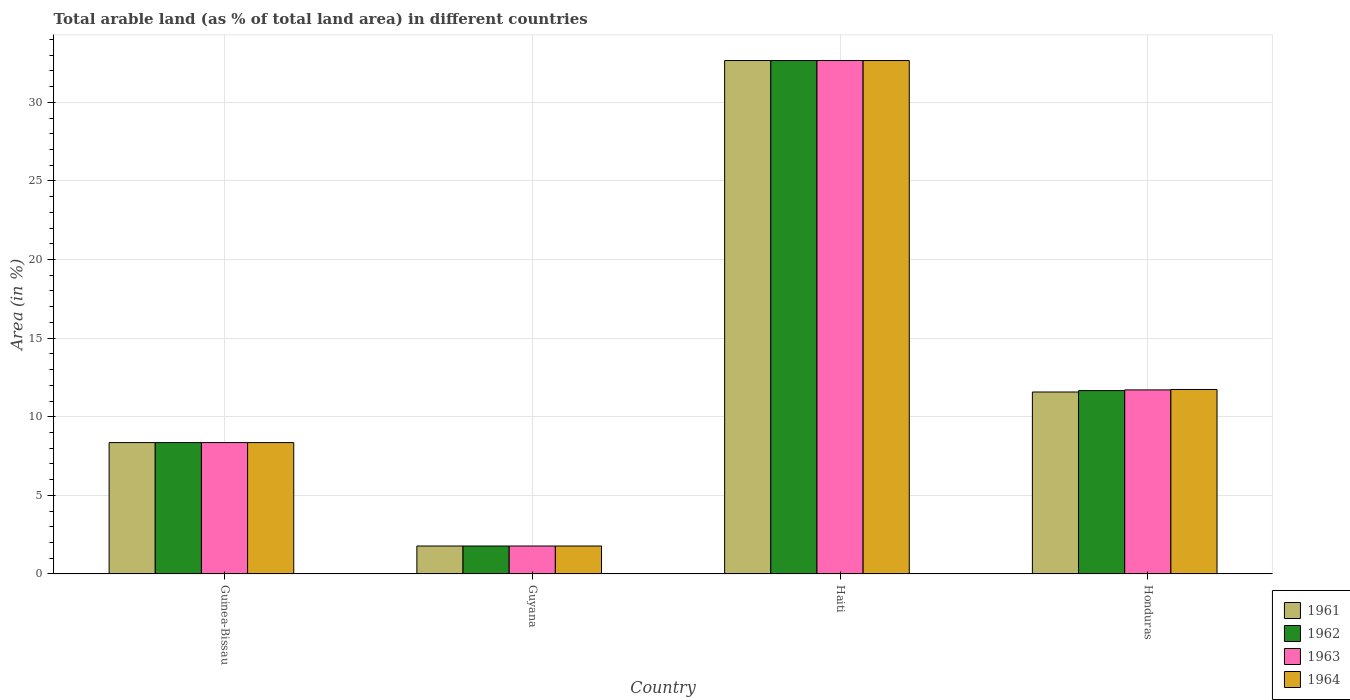How many different coloured bars are there?
Your answer should be compact. 4. How many groups of bars are there?
Your answer should be compact. 4. How many bars are there on the 1st tick from the left?
Offer a terse response. 4. How many bars are there on the 2nd tick from the right?
Ensure brevity in your answer.  4. What is the label of the 4th group of bars from the left?
Ensure brevity in your answer.  Honduras. In how many cases, is the number of bars for a given country not equal to the number of legend labels?
Offer a terse response. 0. What is the percentage of arable land in 1963 in Haiti?
Your response must be concise. 32.66. Across all countries, what is the maximum percentage of arable land in 1963?
Ensure brevity in your answer.  32.66. Across all countries, what is the minimum percentage of arable land in 1961?
Ensure brevity in your answer.  1.78. In which country was the percentage of arable land in 1964 maximum?
Offer a terse response. Haiti. In which country was the percentage of arable land in 1963 minimum?
Your answer should be compact. Guyana. What is the total percentage of arable land in 1962 in the graph?
Offer a terse response. 54.46. What is the difference between the percentage of arable land in 1961 in Haiti and that in Honduras?
Offer a very short reply. 21.08. What is the difference between the percentage of arable land in 1963 in Honduras and the percentage of arable land in 1962 in Haiti?
Give a very brief answer. -20.95. What is the average percentage of arable land in 1962 per country?
Your response must be concise. 13.61. What is the difference between the percentage of arable land of/in 1963 and percentage of arable land of/in 1961 in Haiti?
Keep it short and to the point. 0. What is the ratio of the percentage of arable land in 1964 in Guyana to that in Haiti?
Offer a very short reply. 0.05. Is the percentage of arable land in 1964 in Guyana less than that in Haiti?
Provide a short and direct response. Yes. Is the difference between the percentage of arable land in 1963 in Haiti and Honduras greater than the difference between the percentage of arable land in 1961 in Haiti and Honduras?
Offer a very short reply. No. What is the difference between the highest and the second highest percentage of arable land in 1962?
Provide a succinct answer. 24.3. What is the difference between the highest and the lowest percentage of arable land in 1962?
Your answer should be compact. 30.88. What does the 4th bar from the left in Haiti represents?
Offer a terse response. 1964. What does the 2nd bar from the right in Haiti represents?
Offer a terse response. 1963. Are all the bars in the graph horizontal?
Provide a succinct answer. No. What is the difference between two consecutive major ticks on the Y-axis?
Your response must be concise. 5. Are the values on the major ticks of Y-axis written in scientific E-notation?
Provide a succinct answer. No. Does the graph contain any zero values?
Offer a terse response. No. Does the graph contain grids?
Provide a short and direct response. Yes. What is the title of the graph?
Offer a terse response. Total arable land (as % of total land area) in different countries. What is the label or title of the X-axis?
Your response must be concise. Country. What is the label or title of the Y-axis?
Provide a succinct answer. Area (in %). What is the Area (in %) of 1961 in Guinea-Bissau?
Offer a terse response. 8.36. What is the Area (in %) of 1962 in Guinea-Bissau?
Make the answer very short. 8.36. What is the Area (in %) of 1963 in Guinea-Bissau?
Keep it short and to the point. 8.36. What is the Area (in %) of 1964 in Guinea-Bissau?
Your response must be concise. 8.36. What is the Area (in %) in 1961 in Guyana?
Make the answer very short. 1.78. What is the Area (in %) of 1962 in Guyana?
Give a very brief answer. 1.78. What is the Area (in %) in 1963 in Guyana?
Keep it short and to the point. 1.78. What is the Area (in %) in 1964 in Guyana?
Provide a short and direct response. 1.78. What is the Area (in %) of 1961 in Haiti?
Your answer should be compact. 32.66. What is the Area (in %) in 1962 in Haiti?
Provide a short and direct response. 32.66. What is the Area (in %) in 1963 in Haiti?
Provide a succinct answer. 32.66. What is the Area (in %) of 1964 in Haiti?
Keep it short and to the point. 32.66. What is the Area (in %) of 1961 in Honduras?
Keep it short and to the point. 11.57. What is the Area (in %) of 1962 in Honduras?
Keep it short and to the point. 11.66. What is the Area (in %) in 1963 in Honduras?
Keep it short and to the point. 11.71. What is the Area (in %) of 1964 in Honduras?
Your answer should be very brief. 11.73. Across all countries, what is the maximum Area (in %) of 1961?
Provide a short and direct response. 32.66. Across all countries, what is the maximum Area (in %) of 1962?
Provide a short and direct response. 32.66. Across all countries, what is the maximum Area (in %) in 1963?
Offer a terse response. 32.66. Across all countries, what is the maximum Area (in %) of 1964?
Your answer should be very brief. 32.66. Across all countries, what is the minimum Area (in %) of 1961?
Offer a very short reply. 1.78. Across all countries, what is the minimum Area (in %) of 1962?
Provide a succinct answer. 1.78. Across all countries, what is the minimum Area (in %) of 1963?
Offer a terse response. 1.78. Across all countries, what is the minimum Area (in %) of 1964?
Provide a short and direct response. 1.78. What is the total Area (in %) of 1961 in the graph?
Ensure brevity in your answer.  54.37. What is the total Area (in %) of 1962 in the graph?
Offer a very short reply. 54.46. What is the total Area (in %) of 1963 in the graph?
Your answer should be compact. 54.5. What is the total Area (in %) of 1964 in the graph?
Your response must be concise. 54.53. What is the difference between the Area (in %) of 1961 in Guinea-Bissau and that in Guyana?
Offer a terse response. 6.58. What is the difference between the Area (in %) in 1962 in Guinea-Bissau and that in Guyana?
Give a very brief answer. 6.58. What is the difference between the Area (in %) of 1963 in Guinea-Bissau and that in Guyana?
Offer a very short reply. 6.58. What is the difference between the Area (in %) in 1964 in Guinea-Bissau and that in Guyana?
Provide a succinct answer. 6.58. What is the difference between the Area (in %) in 1961 in Guinea-Bissau and that in Haiti?
Provide a succinct answer. -24.3. What is the difference between the Area (in %) in 1962 in Guinea-Bissau and that in Haiti?
Give a very brief answer. -24.3. What is the difference between the Area (in %) in 1963 in Guinea-Bissau and that in Haiti?
Provide a short and direct response. -24.3. What is the difference between the Area (in %) of 1964 in Guinea-Bissau and that in Haiti?
Give a very brief answer. -24.3. What is the difference between the Area (in %) of 1961 in Guinea-Bissau and that in Honduras?
Your answer should be compact. -3.22. What is the difference between the Area (in %) of 1962 in Guinea-Bissau and that in Honduras?
Your answer should be compact. -3.31. What is the difference between the Area (in %) of 1963 in Guinea-Bissau and that in Honduras?
Make the answer very short. -3.35. What is the difference between the Area (in %) of 1964 in Guinea-Bissau and that in Honduras?
Your answer should be compact. -3.38. What is the difference between the Area (in %) in 1961 in Guyana and that in Haiti?
Your response must be concise. -30.88. What is the difference between the Area (in %) in 1962 in Guyana and that in Haiti?
Offer a terse response. -30.88. What is the difference between the Area (in %) of 1963 in Guyana and that in Haiti?
Make the answer very short. -30.88. What is the difference between the Area (in %) of 1964 in Guyana and that in Haiti?
Offer a terse response. -30.88. What is the difference between the Area (in %) of 1961 in Guyana and that in Honduras?
Make the answer very short. -9.79. What is the difference between the Area (in %) in 1962 in Guyana and that in Honduras?
Your answer should be very brief. -9.88. What is the difference between the Area (in %) in 1963 in Guyana and that in Honduras?
Give a very brief answer. -9.93. What is the difference between the Area (in %) in 1964 in Guyana and that in Honduras?
Give a very brief answer. -9.96. What is the difference between the Area (in %) of 1961 in Haiti and that in Honduras?
Your answer should be very brief. 21.08. What is the difference between the Area (in %) of 1962 in Haiti and that in Honduras?
Your answer should be compact. 20.99. What is the difference between the Area (in %) of 1963 in Haiti and that in Honduras?
Offer a terse response. 20.95. What is the difference between the Area (in %) of 1964 in Haiti and that in Honduras?
Your answer should be very brief. 20.92. What is the difference between the Area (in %) of 1961 in Guinea-Bissau and the Area (in %) of 1962 in Guyana?
Your answer should be very brief. 6.58. What is the difference between the Area (in %) in 1961 in Guinea-Bissau and the Area (in %) in 1963 in Guyana?
Give a very brief answer. 6.58. What is the difference between the Area (in %) in 1961 in Guinea-Bissau and the Area (in %) in 1964 in Guyana?
Offer a terse response. 6.58. What is the difference between the Area (in %) in 1962 in Guinea-Bissau and the Area (in %) in 1963 in Guyana?
Keep it short and to the point. 6.58. What is the difference between the Area (in %) of 1962 in Guinea-Bissau and the Area (in %) of 1964 in Guyana?
Keep it short and to the point. 6.58. What is the difference between the Area (in %) in 1963 in Guinea-Bissau and the Area (in %) in 1964 in Guyana?
Offer a terse response. 6.58. What is the difference between the Area (in %) in 1961 in Guinea-Bissau and the Area (in %) in 1962 in Haiti?
Offer a terse response. -24.3. What is the difference between the Area (in %) of 1961 in Guinea-Bissau and the Area (in %) of 1963 in Haiti?
Make the answer very short. -24.3. What is the difference between the Area (in %) in 1961 in Guinea-Bissau and the Area (in %) in 1964 in Haiti?
Offer a very short reply. -24.3. What is the difference between the Area (in %) of 1962 in Guinea-Bissau and the Area (in %) of 1963 in Haiti?
Provide a succinct answer. -24.3. What is the difference between the Area (in %) of 1962 in Guinea-Bissau and the Area (in %) of 1964 in Haiti?
Your response must be concise. -24.3. What is the difference between the Area (in %) in 1963 in Guinea-Bissau and the Area (in %) in 1964 in Haiti?
Provide a short and direct response. -24.3. What is the difference between the Area (in %) in 1961 in Guinea-Bissau and the Area (in %) in 1962 in Honduras?
Offer a terse response. -3.31. What is the difference between the Area (in %) in 1961 in Guinea-Bissau and the Area (in %) in 1963 in Honduras?
Ensure brevity in your answer.  -3.35. What is the difference between the Area (in %) of 1961 in Guinea-Bissau and the Area (in %) of 1964 in Honduras?
Offer a terse response. -3.38. What is the difference between the Area (in %) of 1962 in Guinea-Bissau and the Area (in %) of 1963 in Honduras?
Your answer should be very brief. -3.35. What is the difference between the Area (in %) in 1962 in Guinea-Bissau and the Area (in %) in 1964 in Honduras?
Give a very brief answer. -3.38. What is the difference between the Area (in %) of 1963 in Guinea-Bissau and the Area (in %) of 1964 in Honduras?
Provide a succinct answer. -3.38. What is the difference between the Area (in %) of 1961 in Guyana and the Area (in %) of 1962 in Haiti?
Ensure brevity in your answer.  -30.88. What is the difference between the Area (in %) of 1961 in Guyana and the Area (in %) of 1963 in Haiti?
Make the answer very short. -30.88. What is the difference between the Area (in %) in 1961 in Guyana and the Area (in %) in 1964 in Haiti?
Offer a terse response. -30.88. What is the difference between the Area (in %) of 1962 in Guyana and the Area (in %) of 1963 in Haiti?
Make the answer very short. -30.88. What is the difference between the Area (in %) of 1962 in Guyana and the Area (in %) of 1964 in Haiti?
Your answer should be compact. -30.88. What is the difference between the Area (in %) of 1963 in Guyana and the Area (in %) of 1964 in Haiti?
Your answer should be compact. -30.88. What is the difference between the Area (in %) of 1961 in Guyana and the Area (in %) of 1962 in Honduras?
Make the answer very short. -9.88. What is the difference between the Area (in %) of 1961 in Guyana and the Area (in %) of 1963 in Honduras?
Your response must be concise. -9.93. What is the difference between the Area (in %) in 1961 in Guyana and the Area (in %) in 1964 in Honduras?
Provide a succinct answer. -9.96. What is the difference between the Area (in %) in 1962 in Guyana and the Area (in %) in 1963 in Honduras?
Ensure brevity in your answer.  -9.93. What is the difference between the Area (in %) in 1962 in Guyana and the Area (in %) in 1964 in Honduras?
Keep it short and to the point. -9.96. What is the difference between the Area (in %) of 1963 in Guyana and the Area (in %) of 1964 in Honduras?
Ensure brevity in your answer.  -9.96. What is the difference between the Area (in %) in 1961 in Haiti and the Area (in %) in 1962 in Honduras?
Provide a succinct answer. 20.99. What is the difference between the Area (in %) in 1961 in Haiti and the Area (in %) in 1963 in Honduras?
Your response must be concise. 20.95. What is the difference between the Area (in %) in 1961 in Haiti and the Area (in %) in 1964 in Honduras?
Your answer should be very brief. 20.92. What is the difference between the Area (in %) of 1962 in Haiti and the Area (in %) of 1963 in Honduras?
Your answer should be very brief. 20.95. What is the difference between the Area (in %) of 1962 in Haiti and the Area (in %) of 1964 in Honduras?
Your answer should be very brief. 20.92. What is the difference between the Area (in %) in 1963 in Haiti and the Area (in %) in 1964 in Honduras?
Provide a succinct answer. 20.92. What is the average Area (in %) in 1961 per country?
Ensure brevity in your answer.  13.59. What is the average Area (in %) in 1962 per country?
Your answer should be compact. 13.61. What is the average Area (in %) of 1963 per country?
Ensure brevity in your answer.  13.63. What is the average Area (in %) of 1964 per country?
Offer a very short reply. 13.63. What is the difference between the Area (in %) of 1962 and Area (in %) of 1964 in Guinea-Bissau?
Your answer should be compact. 0. What is the difference between the Area (in %) of 1963 and Area (in %) of 1964 in Guinea-Bissau?
Offer a very short reply. 0. What is the difference between the Area (in %) in 1961 and Area (in %) in 1962 in Guyana?
Make the answer very short. 0. What is the difference between the Area (in %) in 1961 and Area (in %) in 1963 in Guyana?
Your answer should be compact. 0. What is the difference between the Area (in %) in 1961 and Area (in %) in 1964 in Guyana?
Your response must be concise. 0. What is the difference between the Area (in %) in 1962 and Area (in %) in 1963 in Guyana?
Keep it short and to the point. 0. What is the difference between the Area (in %) in 1963 and Area (in %) in 1964 in Guyana?
Offer a terse response. 0. What is the difference between the Area (in %) of 1961 and Area (in %) of 1962 in Haiti?
Your response must be concise. 0. What is the difference between the Area (in %) in 1961 and Area (in %) in 1964 in Haiti?
Provide a succinct answer. 0. What is the difference between the Area (in %) in 1962 and Area (in %) in 1964 in Haiti?
Keep it short and to the point. 0. What is the difference between the Area (in %) in 1961 and Area (in %) in 1962 in Honduras?
Offer a terse response. -0.09. What is the difference between the Area (in %) in 1961 and Area (in %) in 1963 in Honduras?
Offer a terse response. -0.13. What is the difference between the Area (in %) of 1961 and Area (in %) of 1964 in Honduras?
Provide a succinct answer. -0.16. What is the difference between the Area (in %) of 1962 and Area (in %) of 1963 in Honduras?
Your answer should be very brief. -0.04. What is the difference between the Area (in %) in 1962 and Area (in %) in 1964 in Honduras?
Provide a short and direct response. -0.07. What is the difference between the Area (in %) in 1963 and Area (in %) in 1964 in Honduras?
Your answer should be very brief. -0.03. What is the ratio of the Area (in %) in 1961 in Guinea-Bissau to that in Guyana?
Offer a terse response. 4.7. What is the ratio of the Area (in %) of 1962 in Guinea-Bissau to that in Guyana?
Offer a very short reply. 4.7. What is the ratio of the Area (in %) in 1963 in Guinea-Bissau to that in Guyana?
Provide a short and direct response. 4.7. What is the ratio of the Area (in %) of 1964 in Guinea-Bissau to that in Guyana?
Offer a terse response. 4.7. What is the ratio of the Area (in %) of 1961 in Guinea-Bissau to that in Haiti?
Your answer should be very brief. 0.26. What is the ratio of the Area (in %) of 1962 in Guinea-Bissau to that in Haiti?
Your answer should be compact. 0.26. What is the ratio of the Area (in %) in 1963 in Guinea-Bissau to that in Haiti?
Your answer should be very brief. 0.26. What is the ratio of the Area (in %) in 1964 in Guinea-Bissau to that in Haiti?
Ensure brevity in your answer.  0.26. What is the ratio of the Area (in %) of 1961 in Guinea-Bissau to that in Honduras?
Give a very brief answer. 0.72. What is the ratio of the Area (in %) of 1962 in Guinea-Bissau to that in Honduras?
Give a very brief answer. 0.72. What is the ratio of the Area (in %) of 1963 in Guinea-Bissau to that in Honduras?
Your response must be concise. 0.71. What is the ratio of the Area (in %) in 1964 in Guinea-Bissau to that in Honduras?
Offer a very short reply. 0.71. What is the ratio of the Area (in %) in 1961 in Guyana to that in Haiti?
Offer a terse response. 0.05. What is the ratio of the Area (in %) of 1962 in Guyana to that in Haiti?
Give a very brief answer. 0.05. What is the ratio of the Area (in %) of 1963 in Guyana to that in Haiti?
Offer a very short reply. 0.05. What is the ratio of the Area (in %) of 1964 in Guyana to that in Haiti?
Ensure brevity in your answer.  0.05. What is the ratio of the Area (in %) of 1961 in Guyana to that in Honduras?
Give a very brief answer. 0.15. What is the ratio of the Area (in %) of 1962 in Guyana to that in Honduras?
Ensure brevity in your answer.  0.15. What is the ratio of the Area (in %) of 1963 in Guyana to that in Honduras?
Provide a short and direct response. 0.15. What is the ratio of the Area (in %) in 1964 in Guyana to that in Honduras?
Give a very brief answer. 0.15. What is the ratio of the Area (in %) of 1961 in Haiti to that in Honduras?
Offer a very short reply. 2.82. What is the ratio of the Area (in %) of 1962 in Haiti to that in Honduras?
Offer a very short reply. 2.8. What is the ratio of the Area (in %) of 1963 in Haiti to that in Honduras?
Keep it short and to the point. 2.79. What is the ratio of the Area (in %) of 1964 in Haiti to that in Honduras?
Ensure brevity in your answer.  2.78. What is the difference between the highest and the second highest Area (in %) of 1961?
Offer a very short reply. 21.08. What is the difference between the highest and the second highest Area (in %) of 1962?
Your answer should be very brief. 20.99. What is the difference between the highest and the second highest Area (in %) of 1963?
Your answer should be very brief. 20.95. What is the difference between the highest and the second highest Area (in %) of 1964?
Provide a succinct answer. 20.92. What is the difference between the highest and the lowest Area (in %) in 1961?
Offer a terse response. 30.88. What is the difference between the highest and the lowest Area (in %) of 1962?
Your answer should be compact. 30.88. What is the difference between the highest and the lowest Area (in %) in 1963?
Offer a terse response. 30.88. What is the difference between the highest and the lowest Area (in %) of 1964?
Ensure brevity in your answer.  30.88. 